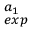<formula> <loc_0><loc_0><loc_500><loc_500>^ { a _ { 1 } } _ { e x p }</formula> 